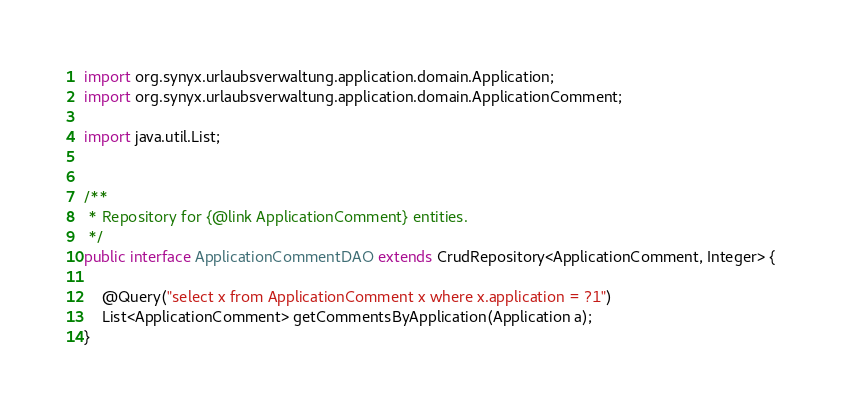Convert code to text. <code><loc_0><loc_0><loc_500><loc_500><_Java_>import org.synyx.urlaubsverwaltung.application.domain.Application;
import org.synyx.urlaubsverwaltung.application.domain.ApplicationComment;

import java.util.List;


/**
 * Repository for {@link ApplicationComment} entities.
 */
public interface ApplicationCommentDAO extends CrudRepository<ApplicationComment, Integer> {

    @Query("select x from ApplicationComment x where x.application = ?1")
    List<ApplicationComment> getCommentsByApplication(Application a);
}
</code> 